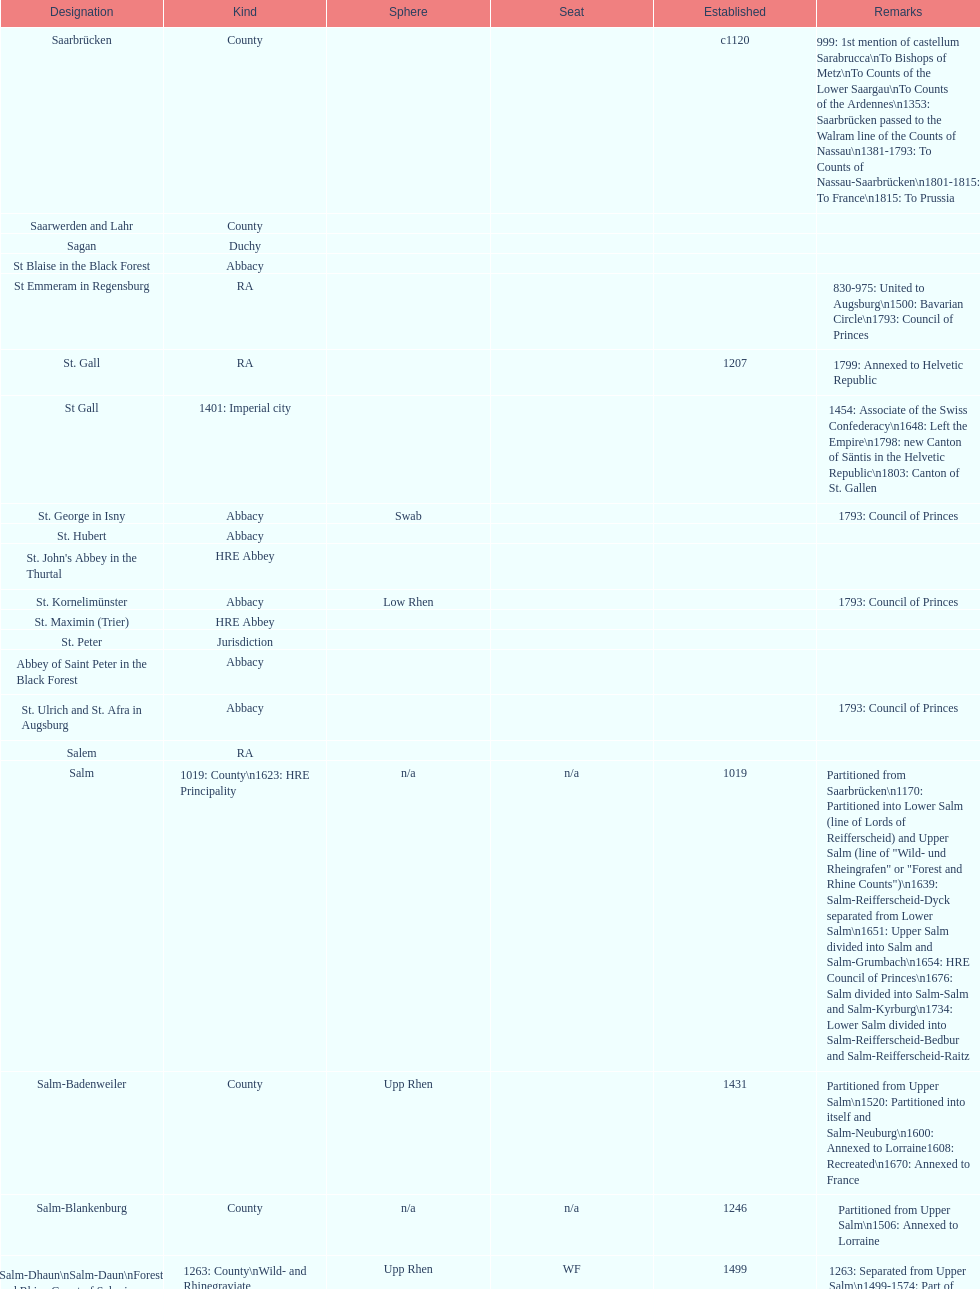Which bench is represented the most? PR. 